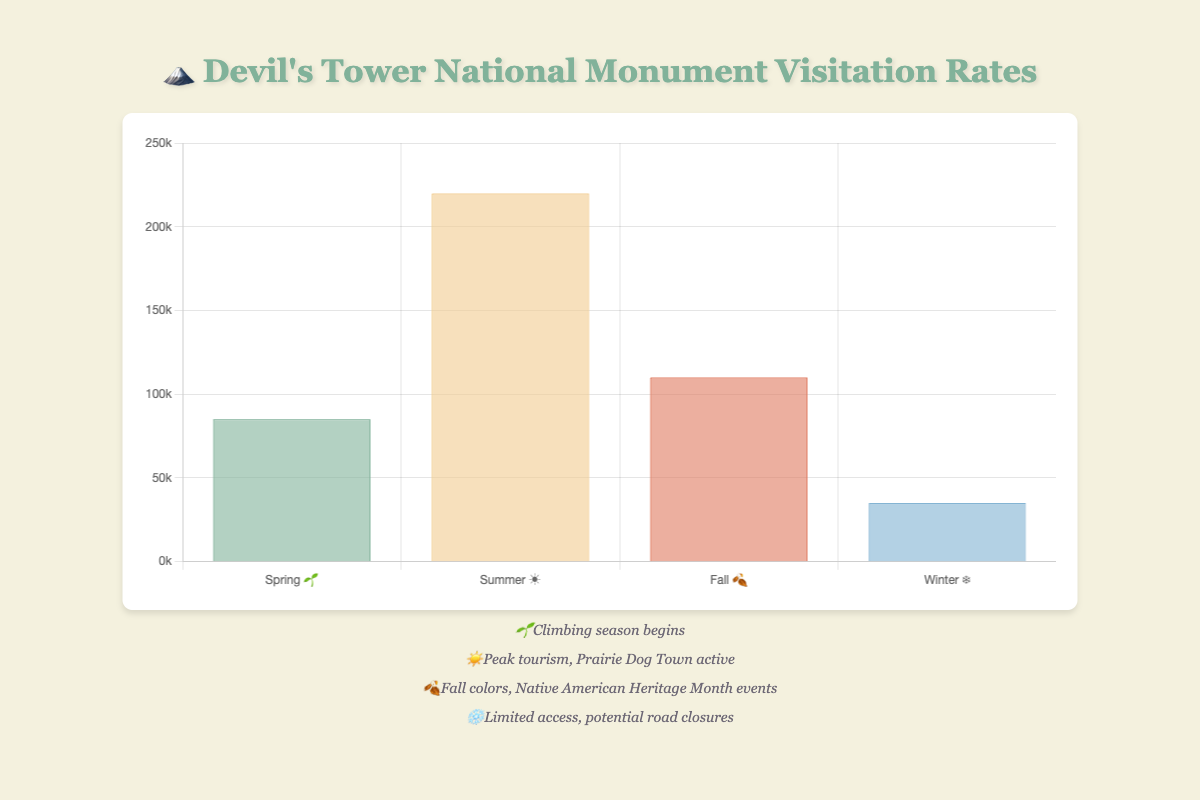What season has the highest visitation? Look at the bar with the greatest height. The summer season has the highest visitation with 220,000 visitors.
Answer: Summer ☀️ What is the total visitation across all seasons? Add the visitation rates for all four seasons (85,000 + 220,000 + 110,000 + 35,000). The total visitation is 450,000.
Answer: 450,000 How much more visitation does summer have compared to winter? Subtract the winter visitation rate from the summer visitation rate (220,000 - 35,000). The difference is 185,000.
Answer: 185,000 What is the average visitation rate per season? Sum all four visitation rates and divide by the number of seasons (450,000 ÷ 4). The average visitation rate is 112,500.
Answer: 112,500 Which season has the lowest visitation rate? Determine the bar with the smallest height, which is winter with 35,000 visitors.
Answer: Winter ❄️ Rank the seasons from highest to lowest based on visitation rates. Compare the heights of the bars and arrange in descending order: Summer (220,000), Fall (110,000), Spring (85,000), Winter (35,000).
Answer: Summer, Fall, Spring, Winter How does the fall visitation compare to spring? Compare the heights of the bars for fall and spring. Fall (110,000) has 25,000 more visitors than spring (85,000).
Answer: Fall has 25,000 more What percentage of the total annual visitation occurs in the summer? Divide the summer visitation by the total visitation and multiply by 100: (220,000 ÷ 450,000) × 100 = 48.89%.
Answer: 48.89% If the winter visitation doubled, how would it compare to spring? If winter visitation doubled: 35,000 × 2 = 70,000. Compare this to spring's 85,000. Winter would still be 15,000 less than spring.
Answer: Winter would still be 15,000 less What additional activities happen in the fall season? According to the notes, in fall there are Native American Heritage Month events and beautiful fall colors.
Answer: Native American Heritage Month events, fall colors 